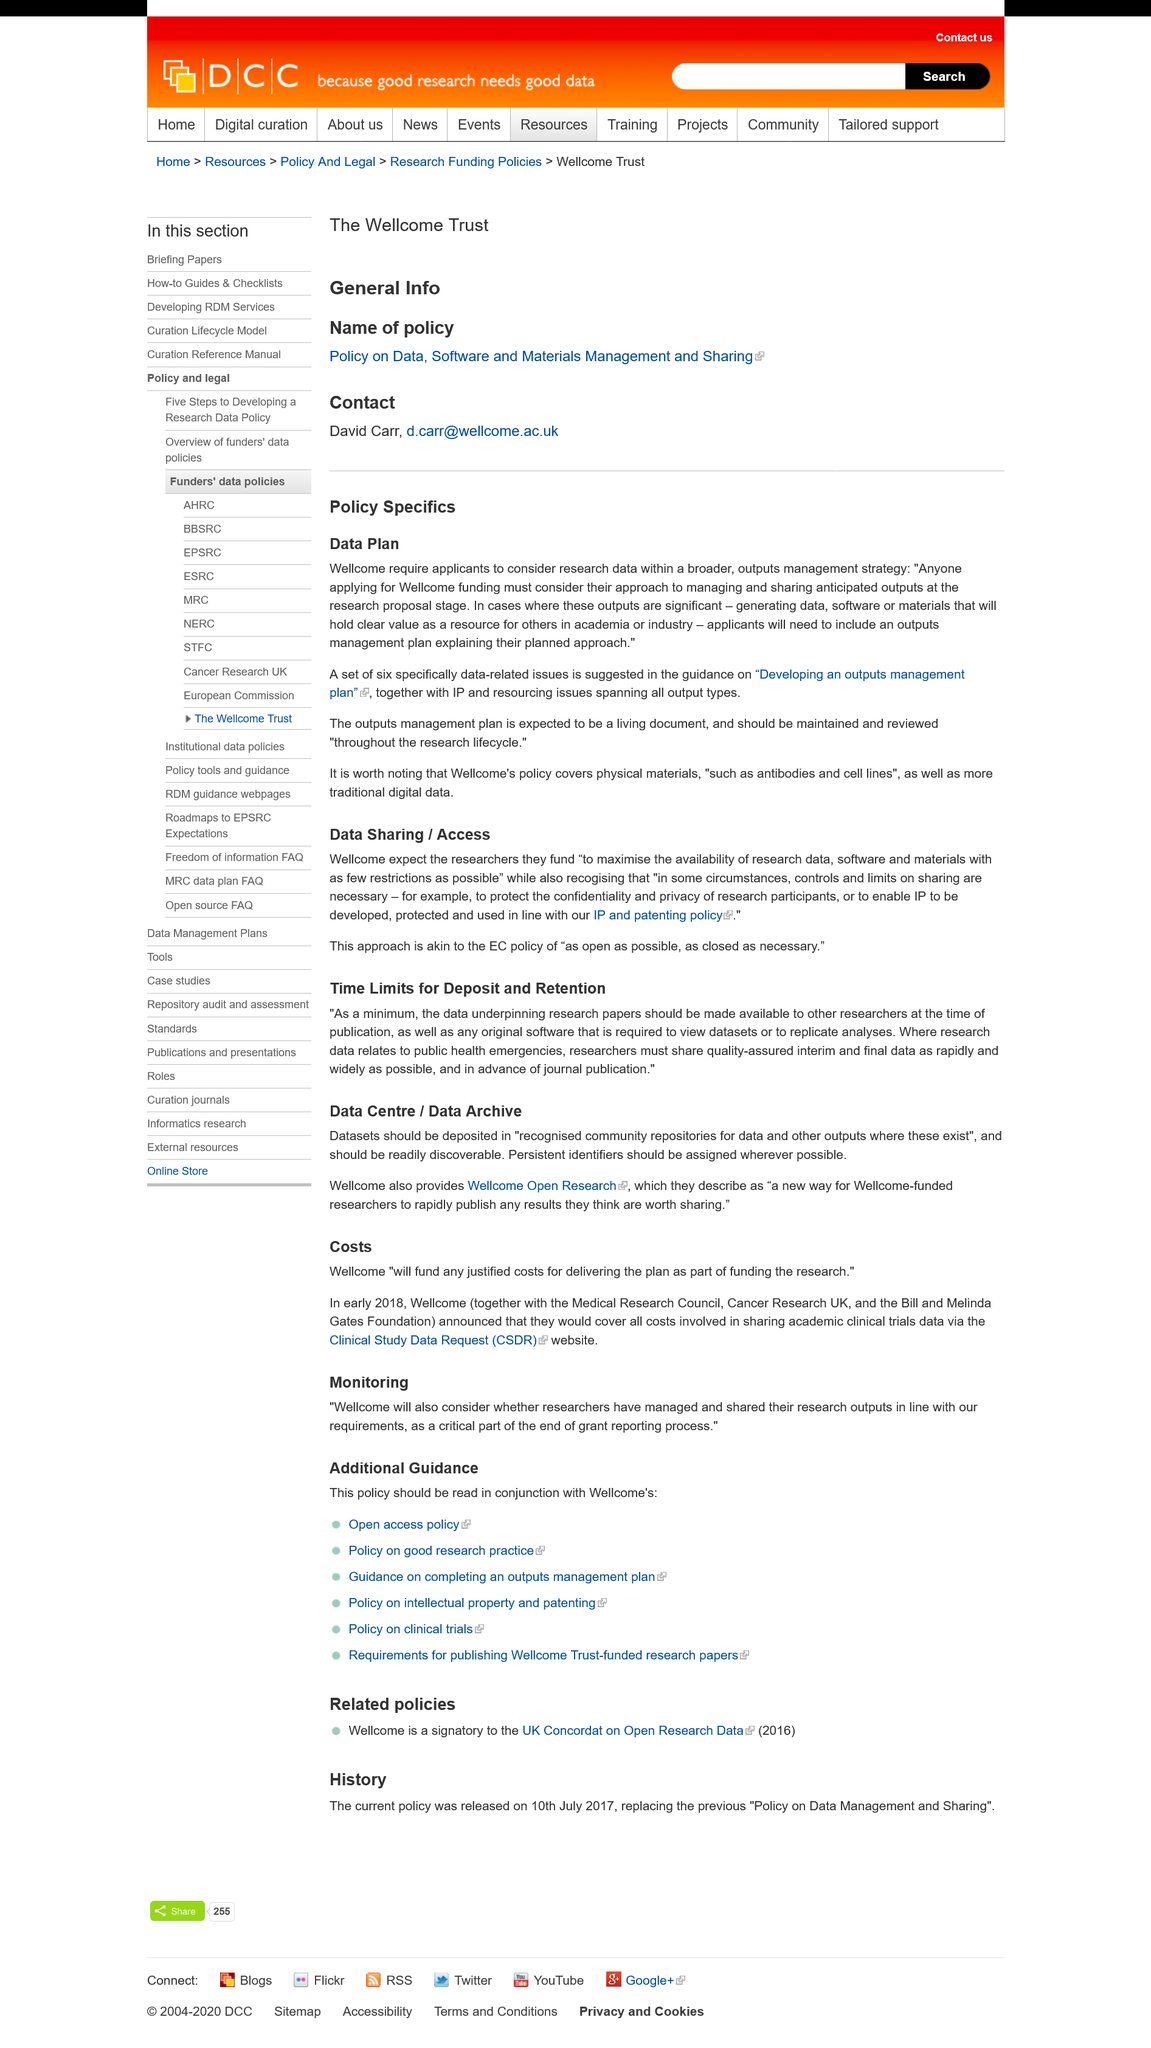Point out several critical features in this image. It is mandatory for all applicants to include a outputs management plan in their proposal, outlining their strategies for managing the expected outputs of the project. The plan, expected to be a living document, suggests six data-related issues. Wellcome requires applications to consider research data within a broader outputs management strategy as part of their entity. 